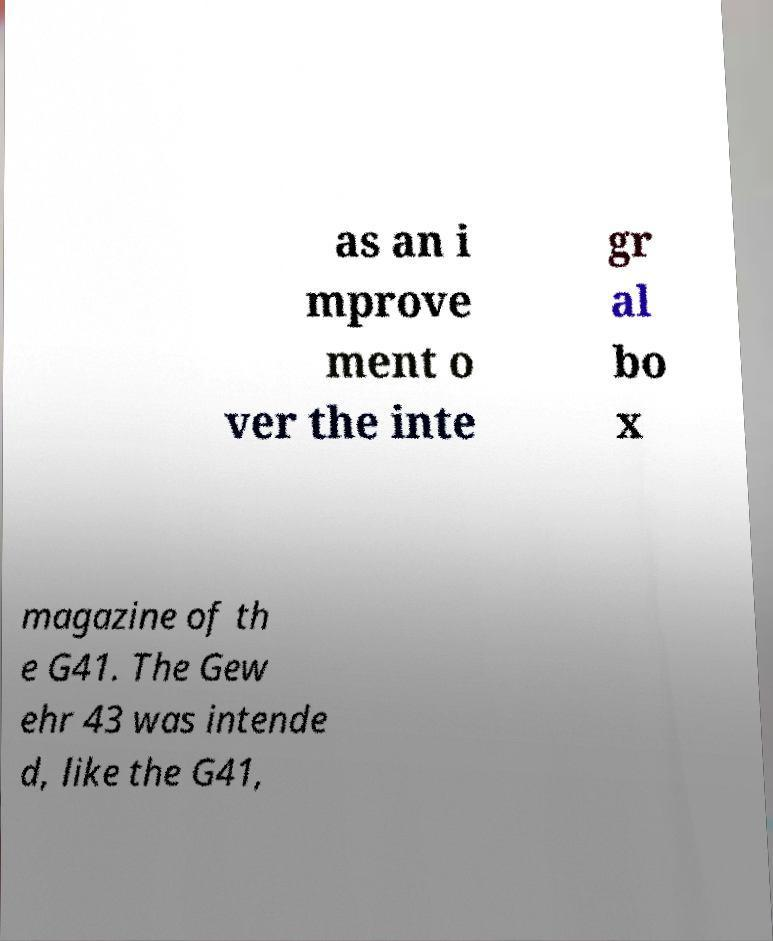I need the written content from this picture converted into text. Can you do that? as an i mprove ment o ver the inte gr al bo x magazine of th e G41. The Gew ehr 43 was intende d, like the G41, 